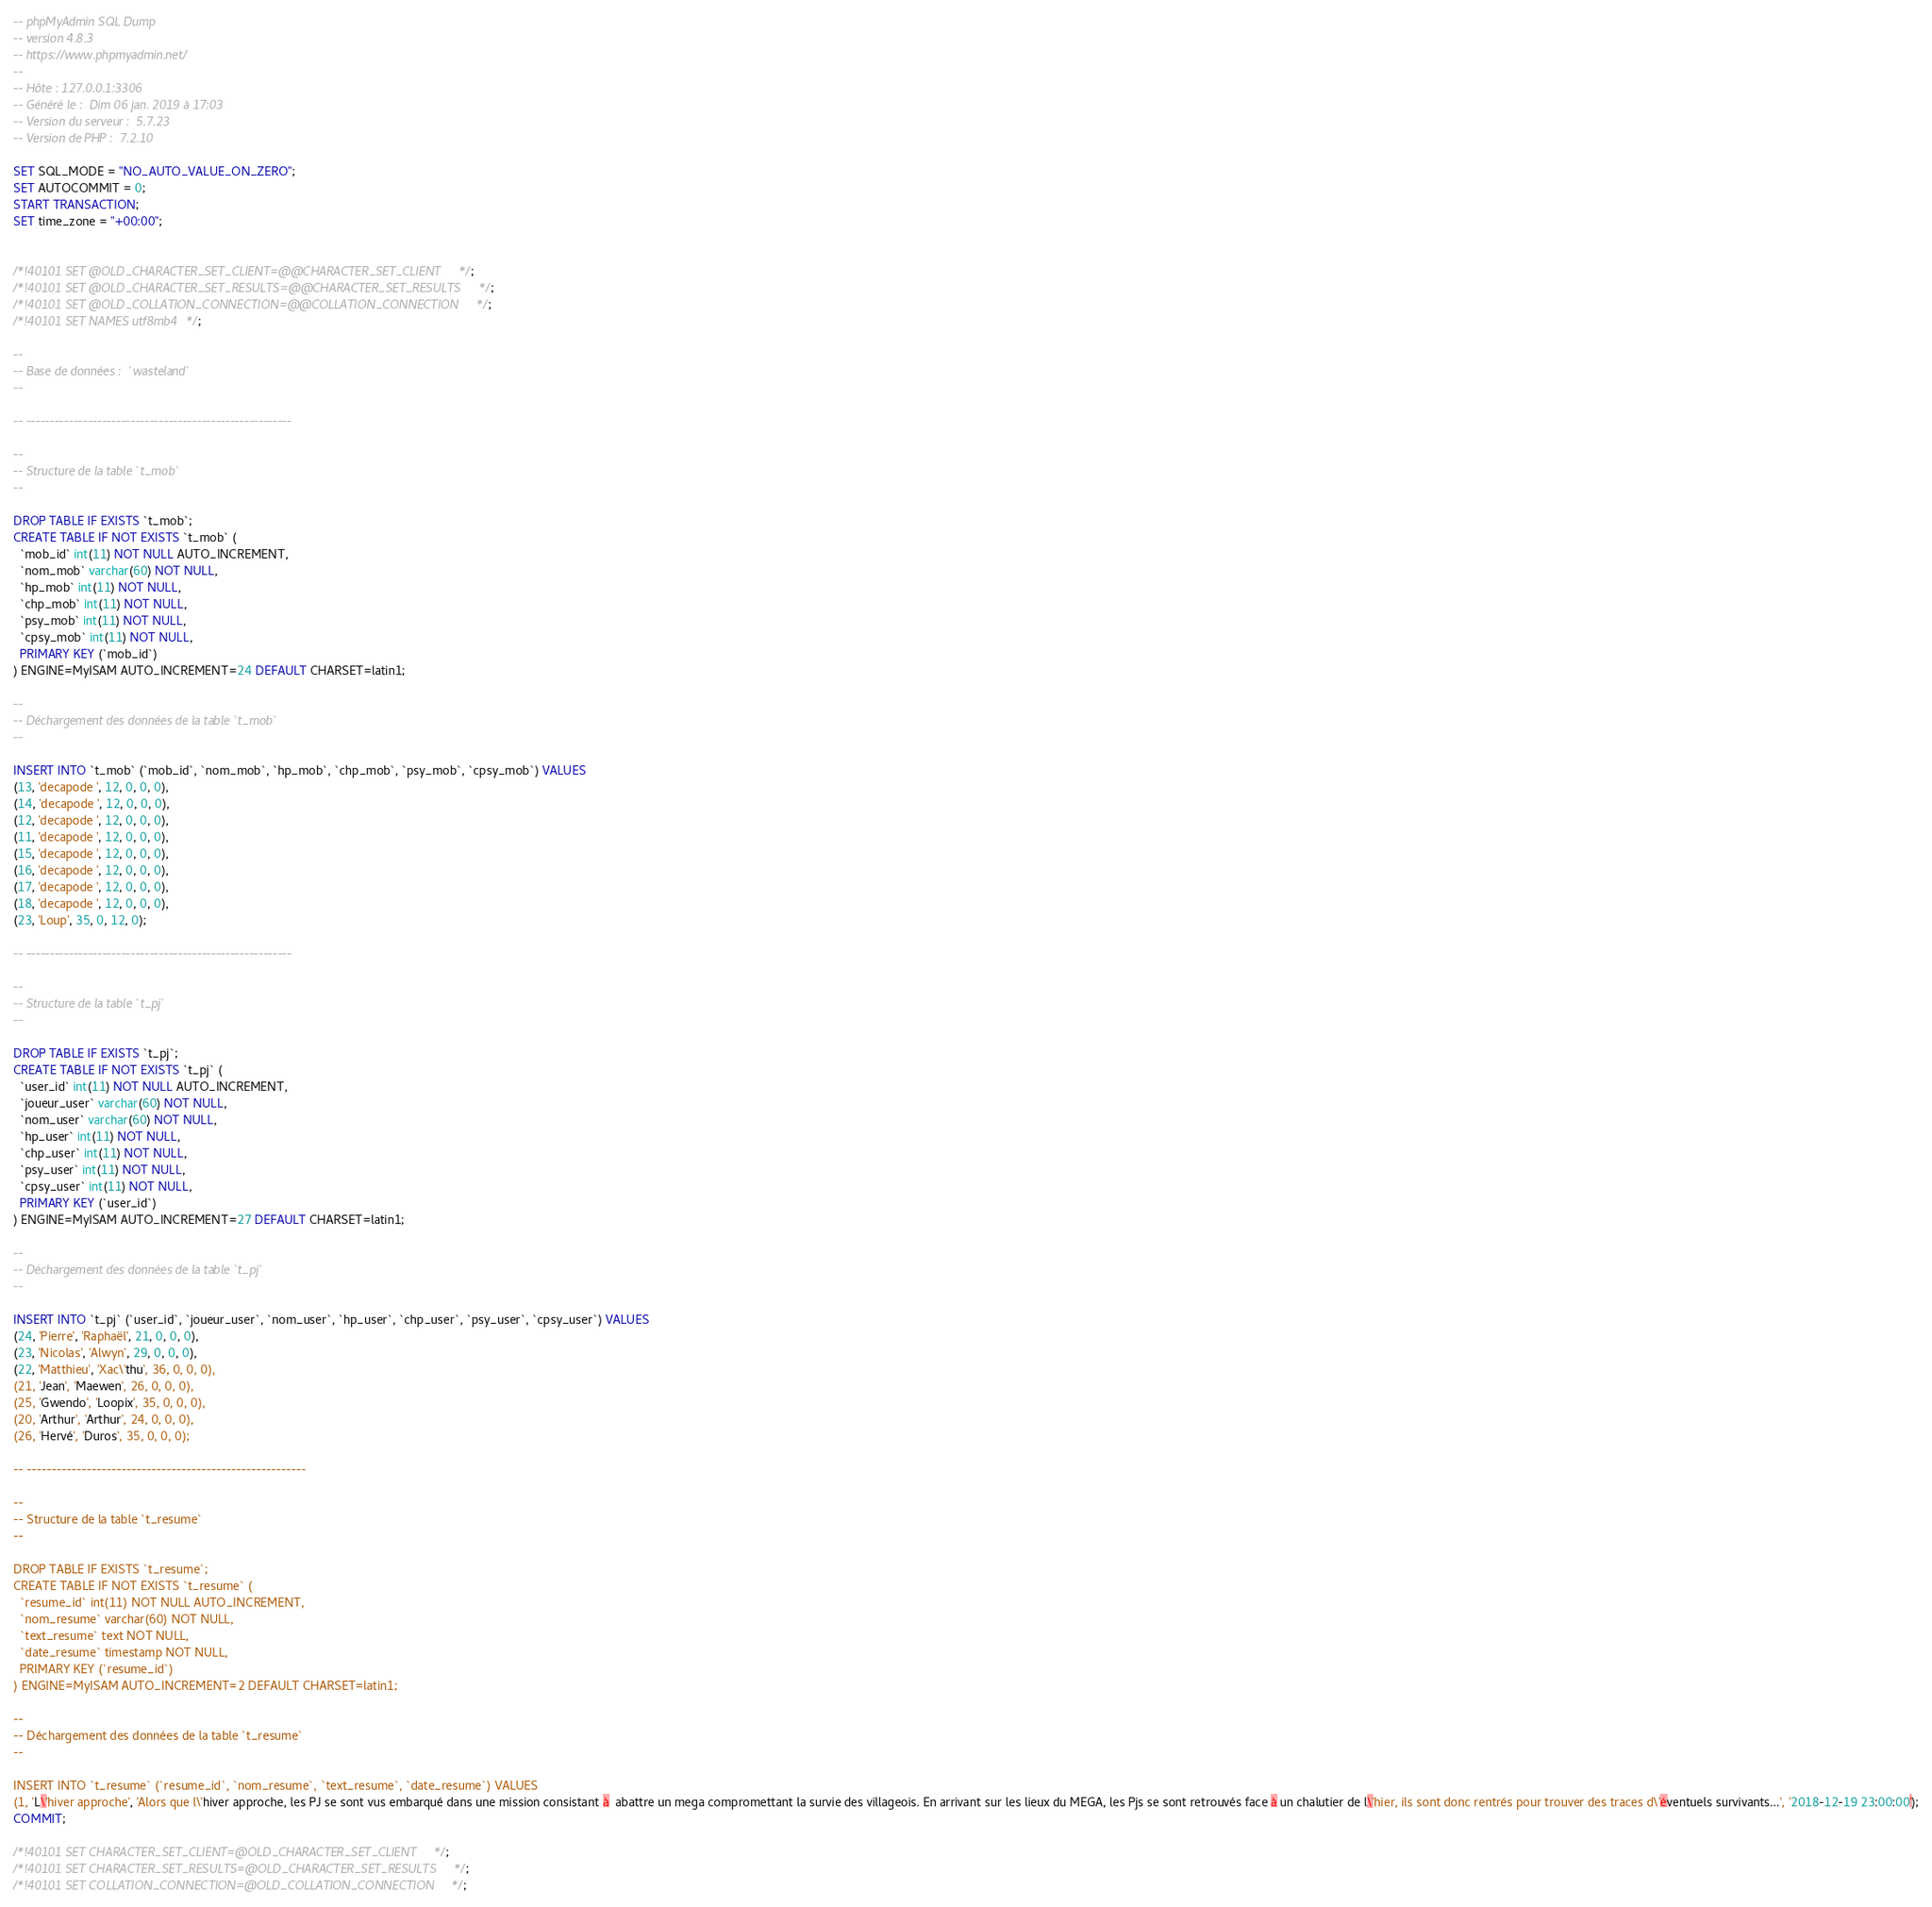<code> <loc_0><loc_0><loc_500><loc_500><_SQL_>-- phpMyAdmin SQL Dump
-- version 4.8.3
-- https://www.phpmyadmin.net/
--
-- Hôte : 127.0.0.1:3306
-- Généré le :  Dim 06 jan. 2019 à 17:03
-- Version du serveur :  5.7.23
-- Version de PHP :  7.2.10

SET SQL_MODE = "NO_AUTO_VALUE_ON_ZERO";
SET AUTOCOMMIT = 0;
START TRANSACTION;
SET time_zone = "+00:00";


/*!40101 SET @OLD_CHARACTER_SET_CLIENT=@@CHARACTER_SET_CLIENT */;
/*!40101 SET @OLD_CHARACTER_SET_RESULTS=@@CHARACTER_SET_RESULTS */;
/*!40101 SET @OLD_COLLATION_CONNECTION=@@COLLATION_CONNECTION */;
/*!40101 SET NAMES utf8mb4 */;

--
-- Base de données :  `wasteland`
--

-- --------------------------------------------------------

--
-- Structure de la table `t_mob`
--

DROP TABLE IF EXISTS `t_mob`;
CREATE TABLE IF NOT EXISTS `t_mob` (
  `mob_id` int(11) NOT NULL AUTO_INCREMENT,
  `nom_mob` varchar(60) NOT NULL,
  `hp_mob` int(11) NOT NULL,
  `chp_mob` int(11) NOT NULL,
  `psy_mob` int(11) NOT NULL,
  `cpsy_mob` int(11) NOT NULL,
  PRIMARY KEY (`mob_id`)
) ENGINE=MyISAM AUTO_INCREMENT=24 DEFAULT CHARSET=latin1;

--
-- Déchargement des données de la table `t_mob`
--

INSERT INTO `t_mob` (`mob_id`, `nom_mob`, `hp_mob`, `chp_mob`, `psy_mob`, `cpsy_mob`) VALUES
(13, 'decapode ', 12, 0, 0, 0),
(14, 'decapode ', 12, 0, 0, 0),
(12, 'decapode ', 12, 0, 0, 0),
(11, 'decapode ', 12, 0, 0, 0),
(15, 'decapode ', 12, 0, 0, 0),
(16, 'decapode ', 12, 0, 0, 0),
(17, 'decapode ', 12, 0, 0, 0),
(18, 'decapode ', 12, 0, 0, 0),
(23, 'Loup', 35, 0, 12, 0);

-- --------------------------------------------------------

--
-- Structure de la table `t_pj`
--

DROP TABLE IF EXISTS `t_pj`;
CREATE TABLE IF NOT EXISTS `t_pj` (
  `user_id` int(11) NOT NULL AUTO_INCREMENT,
  `joueur_user` varchar(60) NOT NULL,
  `nom_user` varchar(60) NOT NULL,
  `hp_user` int(11) NOT NULL,
  `chp_user` int(11) NOT NULL,
  `psy_user` int(11) NOT NULL,
  `cpsy_user` int(11) NOT NULL,
  PRIMARY KEY (`user_id`)
) ENGINE=MyISAM AUTO_INCREMENT=27 DEFAULT CHARSET=latin1;

--
-- Déchargement des données de la table `t_pj`
--

INSERT INTO `t_pj` (`user_id`, `joueur_user`, `nom_user`, `hp_user`, `chp_user`, `psy_user`, `cpsy_user`) VALUES
(24, 'Pierre', 'Raphaël', 21, 0, 0, 0),
(23, 'Nicolas', 'Alwyn', 29, 0, 0, 0),
(22, 'Matthieu', 'Xac\'thu', 36, 0, 0, 0),
(21, 'Jean', 'Maewen', 26, 0, 0, 0),
(25, 'Gwendo', 'Loopix', 35, 0, 0, 0),
(20, 'Arthur', 'Arthur', 24, 0, 0, 0),
(26, 'Hervé', 'Duros', 35, 0, 0, 0);

-- --------------------------------------------------------

--
-- Structure de la table `t_resume`
--

DROP TABLE IF EXISTS `t_resume`;
CREATE TABLE IF NOT EXISTS `t_resume` (
  `resume_id` int(11) NOT NULL AUTO_INCREMENT,
  `nom_resume` varchar(60) NOT NULL,
  `text_resume` text NOT NULL,
  `date_resume` timestamp NOT NULL,
  PRIMARY KEY (`resume_id`)
) ENGINE=MyISAM AUTO_INCREMENT=2 DEFAULT CHARSET=latin1;

--
-- Déchargement des données de la table `t_resume`
--

INSERT INTO `t_resume` (`resume_id`, `nom_resume`, `text_resume`, `date_resume`) VALUES
(1, 'L\'hiver approche', 'Alors que l\'hiver approche, les PJ se sont vus embarqué dans une mission consistant à  abattre un mega compromettant la survie des villageois. En arrivant sur les lieux du MEGA, les Pjs se sont retrouvés face à un chalutier de l\'hier, ils sont donc rentrés pour trouver des traces d\'éventuels survivants...', '2018-12-19 23:00:00');
COMMIT;

/*!40101 SET CHARACTER_SET_CLIENT=@OLD_CHARACTER_SET_CLIENT */;
/*!40101 SET CHARACTER_SET_RESULTS=@OLD_CHARACTER_SET_RESULTS */;
/*!40101 SET COLLATION_CONNECTION=@OLD_COLLATION_CONNECTION */;
</code> 